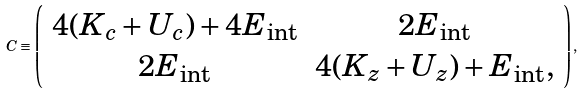Convert formula to latex. <formula><loc_0><loc_0><loc_500><loc_500>C \equiv \left ( \begin{array} { c c } 4 ( K _ { c } + U _ { c } ) + 4 E _ { \text {int} } & 2 E _ { \text {int} } \\ 2 E _ { \text {int} } & 4 ( K _ { z } + U _ { z } ) + E _ { \text {int} } , \end{array} \right ) ,</formula> 